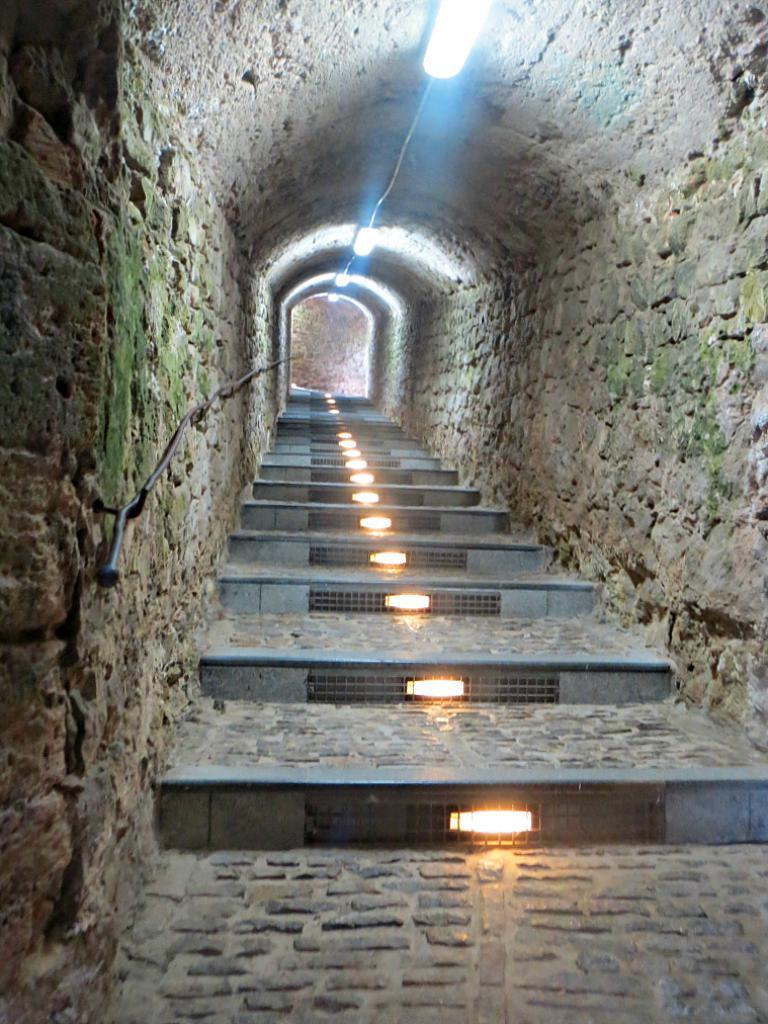What type of transportation is depicted in the image? There is a subway in the image. What can be found inside the subway? There are steps inside the subway. What feature is present on the roof of the subway? There are lights fitted to the roof of the subway. What type of grass is growing on the roof of the subway? There is no grass present on the roof of the subway; it is a subway station with lights fitted to the roof. 